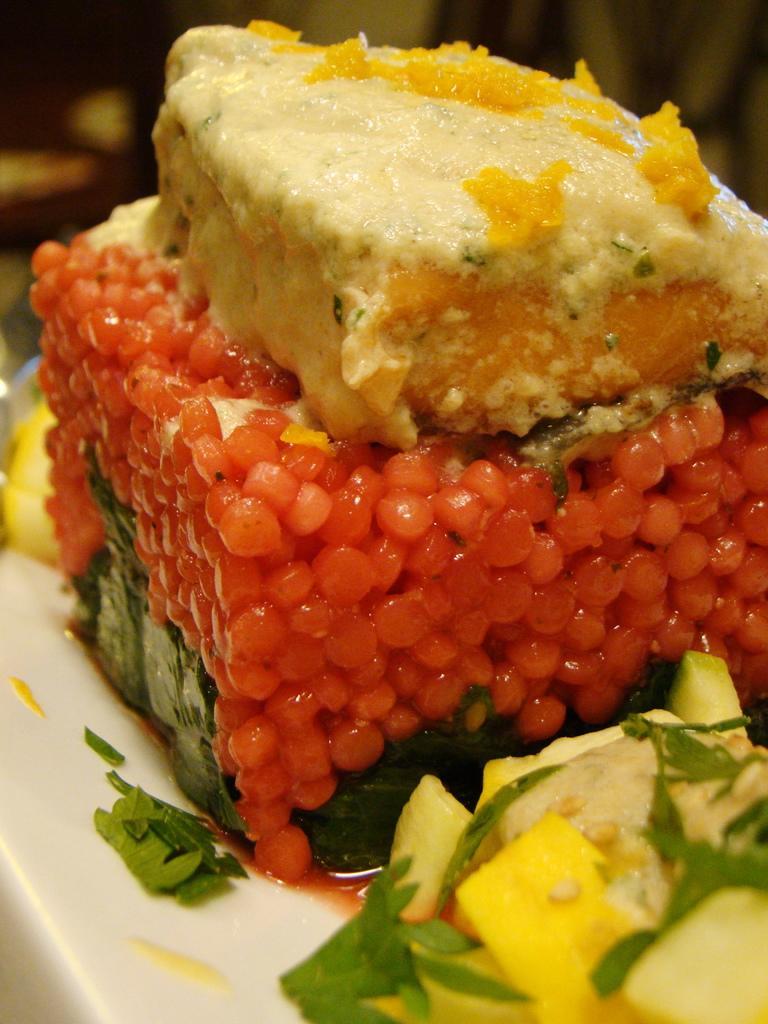How would you summarize this image in a sentence or two? In this picture, we can see different kind of food on an object and there is a blurred background. 